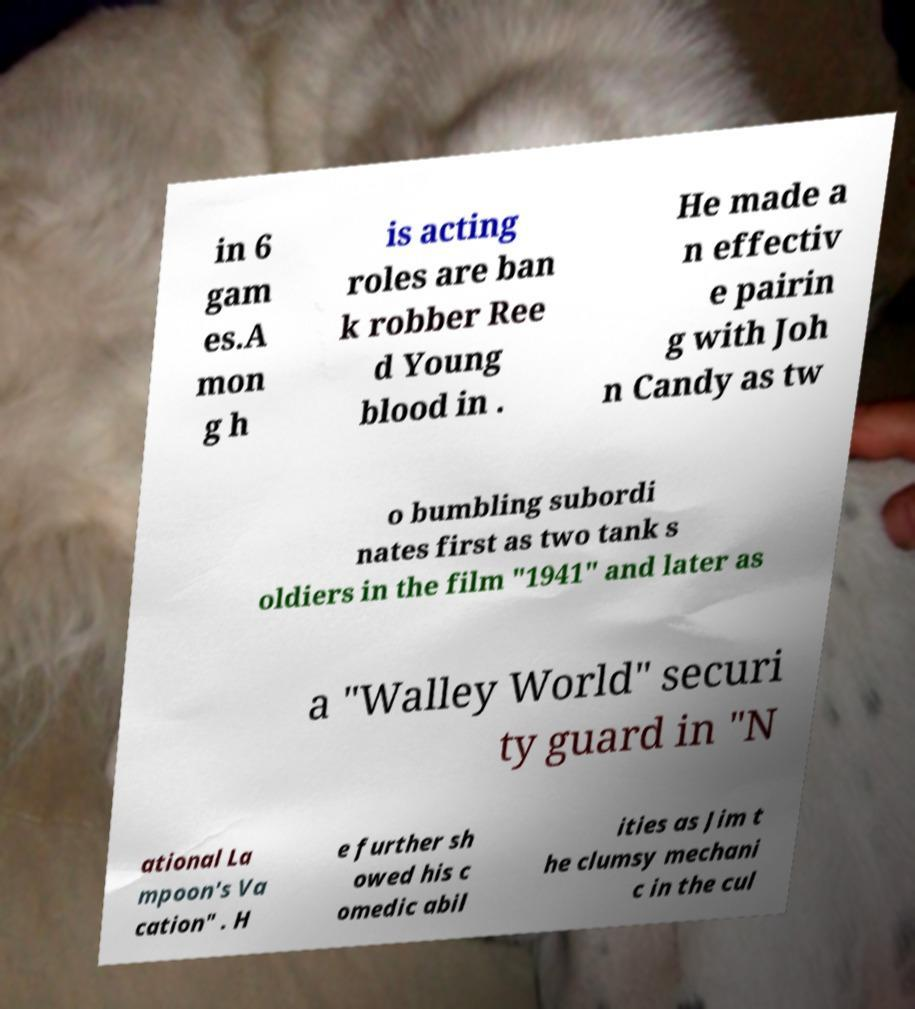There's text embedded in this image that I need extracted. Can you transcribe it verbatim? in 6 gam es.A mon g h is acting roles are ban k robber Ree d Young blood in . He made a n effectiv e pairin g with Joh n Candy as tw o bumbling subordi nates first as two tank s oldiers in the film "1941" and later as a "Walley World" securi ty guard in "N ational La mpoon's Va cation" . H e further sh owed his c omedic abil ities as Jim t he clumsy mechani c in the cul 